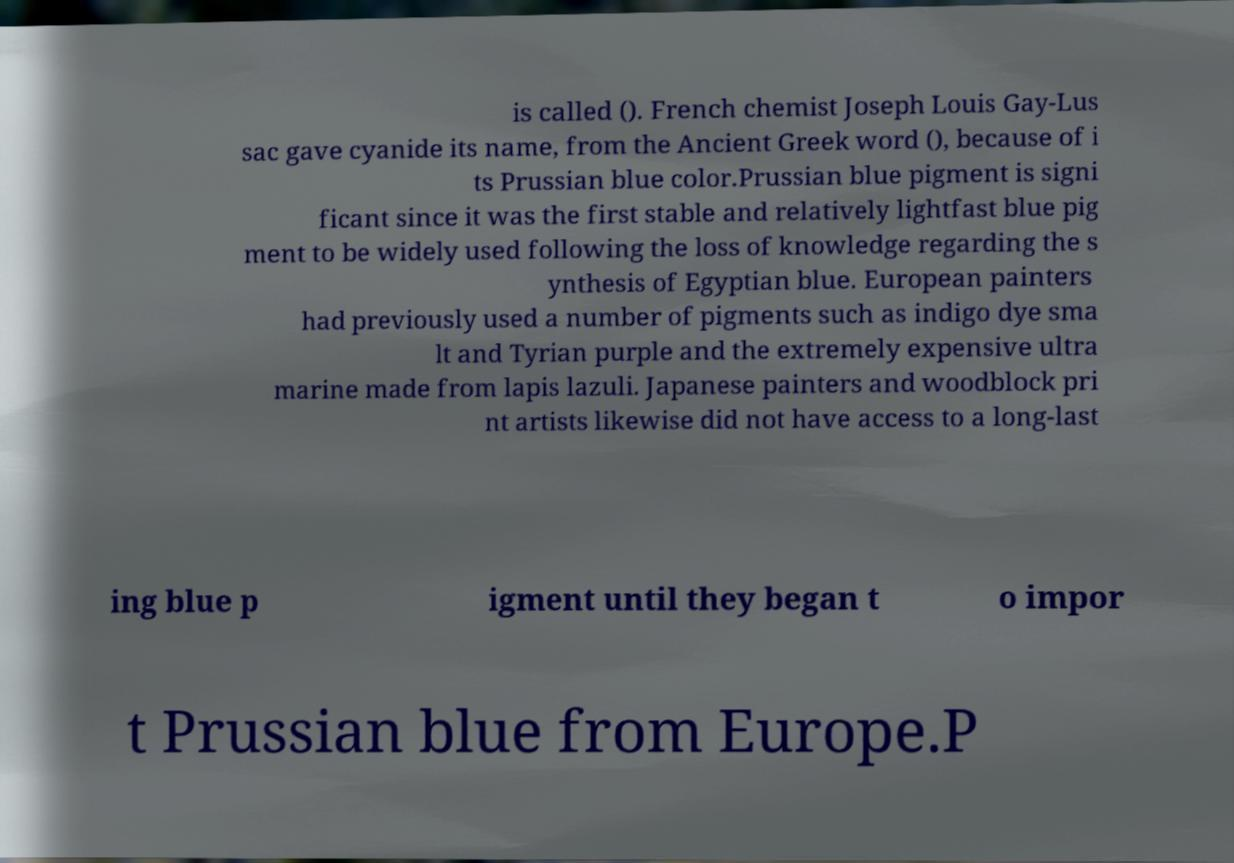There's text embedded in this image that I need extracted. Can you transcribe it verbatim? is called (). French chemist Joseph Louis Gay-Lus sac gave cyanide its name, from the Ancient Greek word (), because of i ts Prussian blue color.Prussian blue pigment is signi ficant since it was the first stable and relatively lightfast blue pig ment to be widely used following the loss of knowledge regarding the s ynthesis of Egyptian blue. European painters had previously used a number of pigments such as indigo dye sma lt and Tyrian purple and the extremely expensive ultra marine made from lapis lazuli. Japanese painters and woodblock pri nt artists likewise did not have access to a long-last ing blue p igment until they began t o impor t Prussian blue from Europe.P 